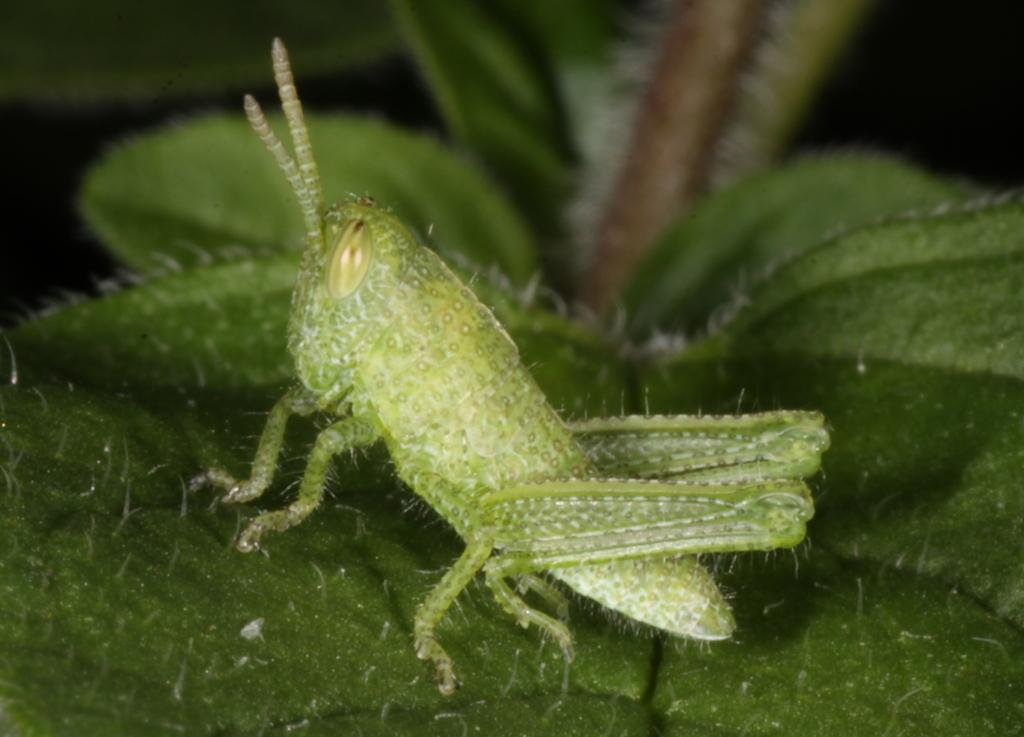What is the main subject of the image? There is a grasshopper in the image. Where is the grasshopper located? The grasshopper is on a leaf. What color is the sky in the image? There is no sky visible in the image; it focuses on the grasshopper on a leaf. What is the grasshopper's attention drawn to in the image? The image does not show the grasshopper's attention being drawn to anything specific. 